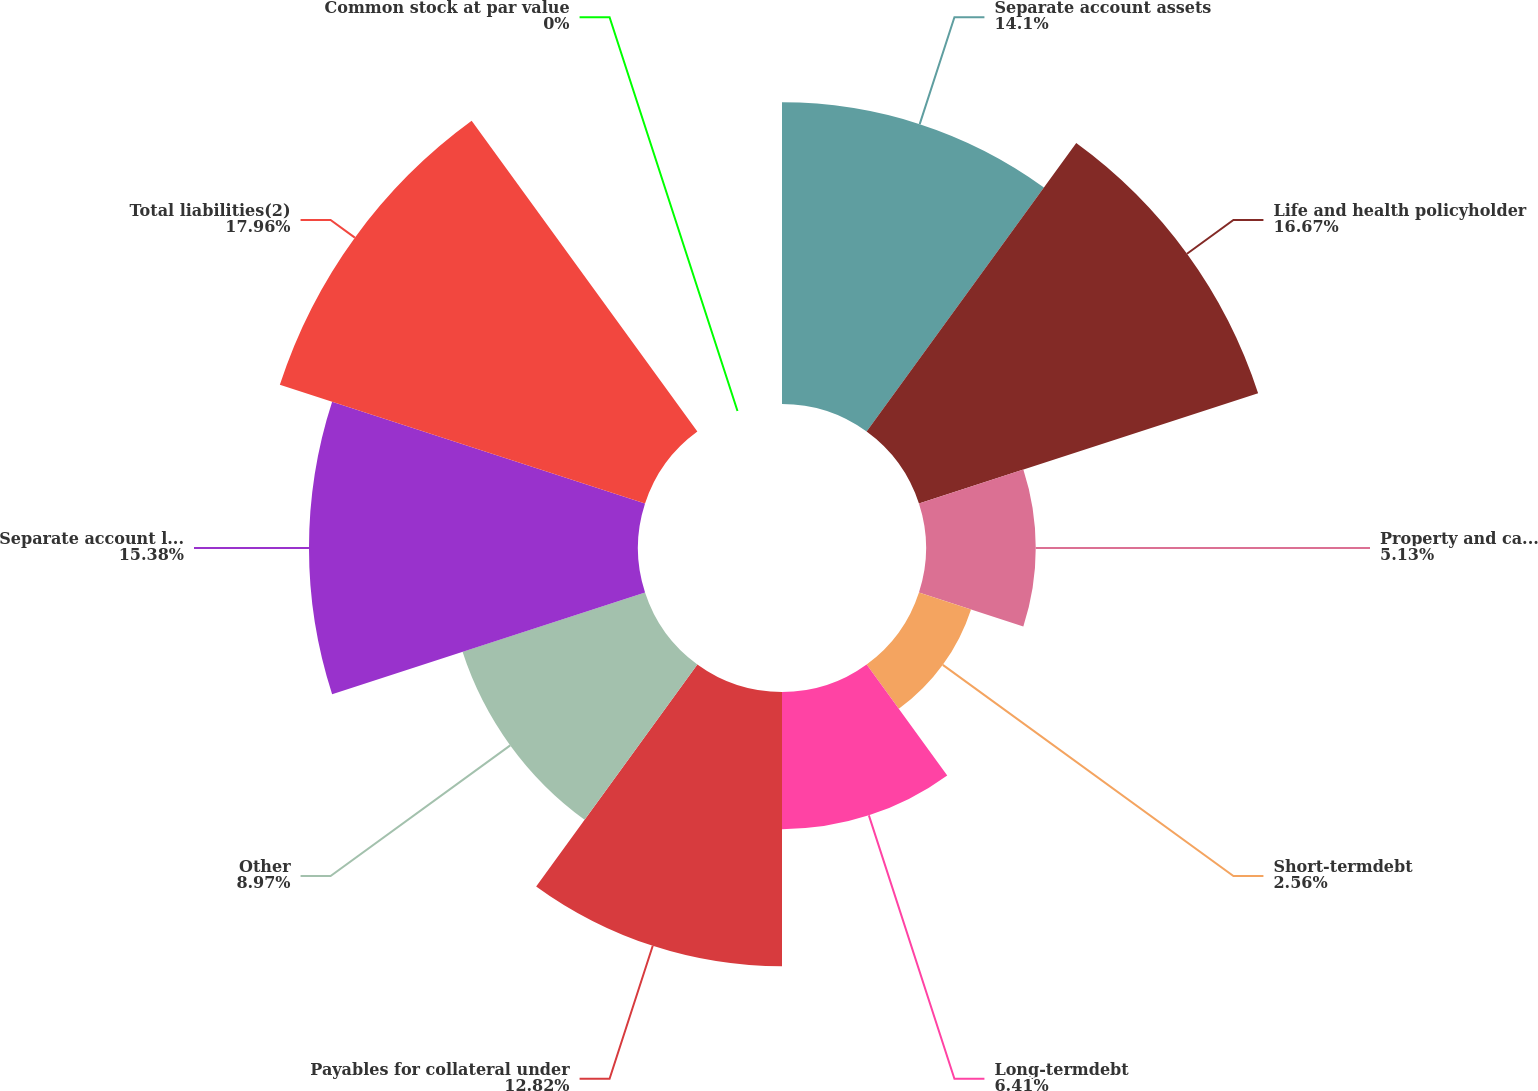<chart> <loc_0><loc_0><loc_500><loc_500><pie_chart><fcel>Separate account assets<fcel>Life and health policyholder<fcel>Property and casualty<fcel>Short-termdebt<fcel>Long-termdebt<fcel>Payables for collateral under<fcel>Other<fcel>Separate account liabilities<fcel>Total liabilities(2)<fcel>Common stock at par value<nl><fcel>14.1%<fcel>16.67%<fcel>5.13%<fcel>2.56%<fcel>6.41%<fcel>12.82%<fcel>8.97%<fcel>15.38%<fcel>17.95%<fcel>0.0%<nl></chart> 